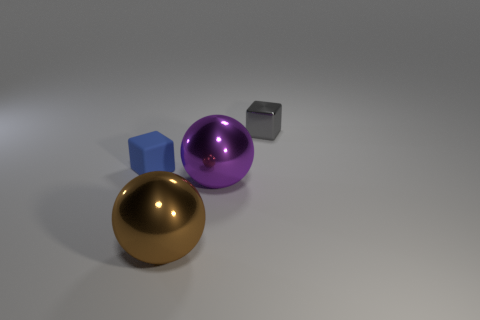What shape is the small gray thing behind the purple sphere? cube 